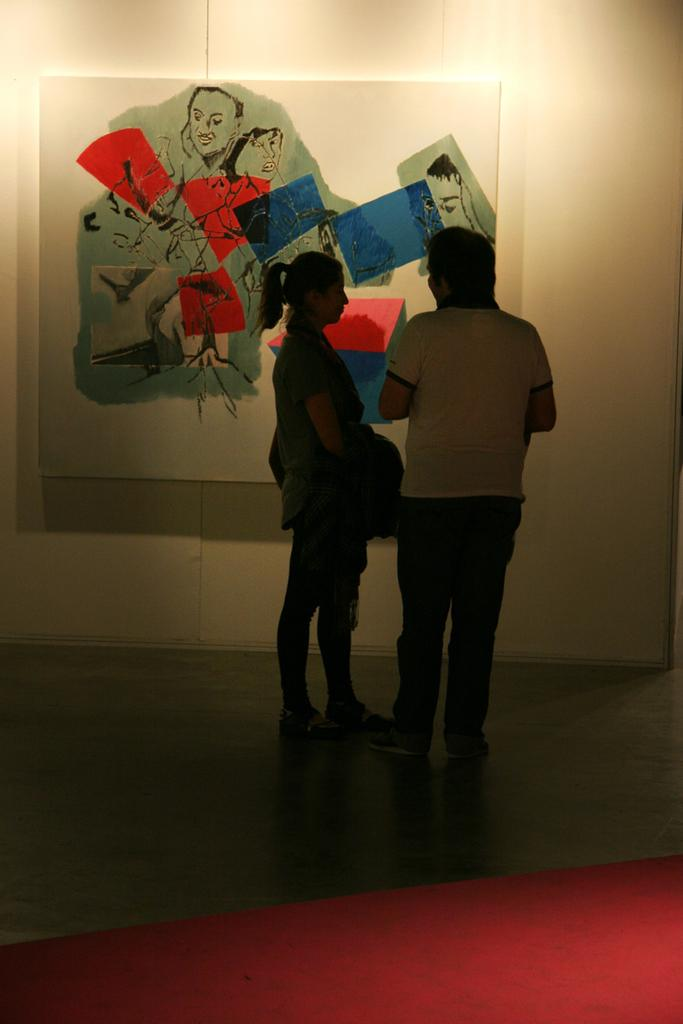How many people are present in the image? There are two people standing in the image. What can be seen on the wall in the image? There is a board on the wall in the image, and a painting is on the board. What is on the floor in the image? There is a carpet on the floor in the image. What type of religious ceremony is taking place in the image? There is no indication of a religious ceremony in the image; it simply shows two people, a board with a painting, and a carpet on the floor. Can you hear any horns or drums in the image? There is no sound present in the image, so it is impossible to determine if any horns or drums can be heard. 